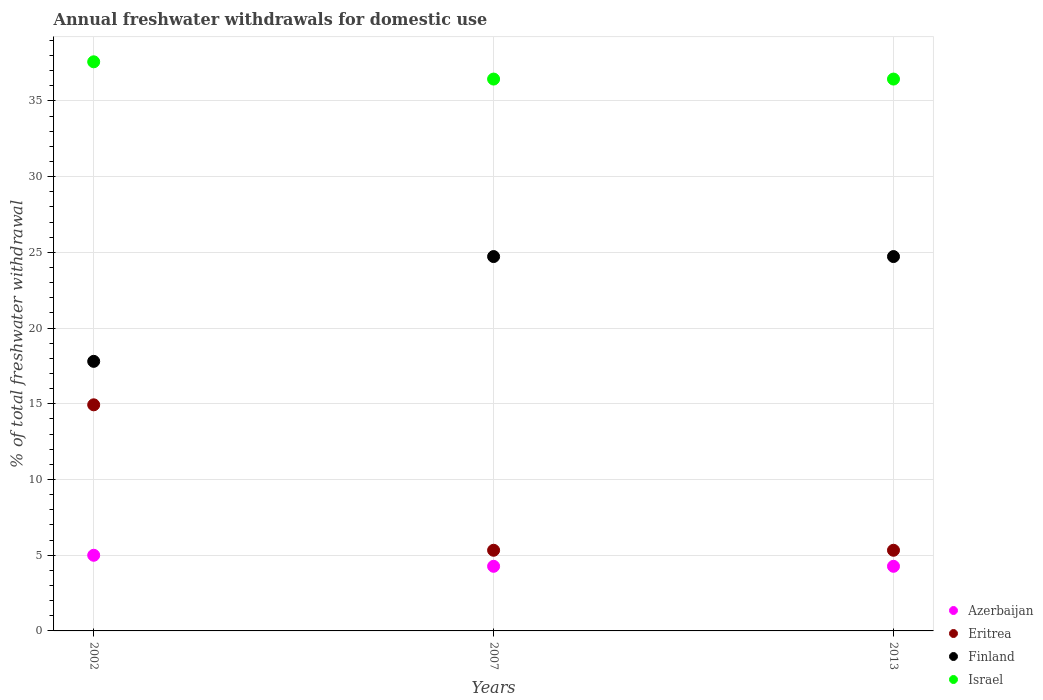What is the total annual withdrawals from freshwater in Eritrea in 2002?
Ensure brevity in your answer.  14.93. Across all years, what is the maximum total annual withdrawals from freshwater in Finland?
Ensure brevity in your answer.  24.72. In which year was the total annual withdrawals from freshwater in Finland maximum?
Give a very brief answer. 2007. What is the total total annual withdrawals from freshwater in Israel in the graph?
Your answer should be very brief. 110.46. What is the difference between the total annual withdrawals from freshwater in Finland in 2002 and that in 2013?
Give a very brief answer. -6.92. What is the difference between the total annual withdrawals from freshwater in Finland in 2002 and the total annual withdrawals from freshwater in Israel in 2013?
Your response must be concise. -18.64. What is the average total annual withdrawals from freshwater in Eritrea per year?
Keep it short and to the point. 8.53. In the year 2002, what is the difference between the total annual withdrawals from freshwater in Finland and total annual withdrawals from freshwater in Azerbaijan?
Your answer should be very brief. 12.8. In how many years, is the total annual withdrawals from freshwater in Azerbaijan greater than 14 %?
Your response must be concise. 0. What is the ratio of the total annual withdrawals from freshwater in Finland in 2002 to that in 2007?
Offer a terse response. 0.72. What is the difference between the highest and the second highest total annual withdrawals from freshwater in Israel?
Your answer should be very brief. 1.14. What is the difference between the highest and the lowest total annual withdrawals from freshwater in Finland?
Offer a terse response. 6.92. In how many years, is the total annual withdrawals from freshwater in Finland greater than the average total annual withdrawals from freshwater in Finland taken over all years?
Ensure brevity in your answer.  2. Is it the case that in every year, the sum of the total annual withdrawals from freshwater in Azerbaijan and total annual withdrawals from freshwater in Finland  is greater than the sum of total annual withdrawals from freshwater in Eritrea and total annual withdrawals from freshwater in Israel?
Ensure brevity in your answer.  Yes. Is it the case that in every year, the sum of the total annual withdrawals from freshwater in Israel and total annual withdrawals from freshwater in Azerbaijan  is greater than the total annual withdrawals from freshwater in Eritrea?
Make the answer very short. Yes. Does the total annual withdrawals from freshwater in Finland monotonically increase over the years?
Offer a very short reply. No. Is the total annual withdrawals from freshwater in Israel strictly greater than the total annual withdrawals from freshwater in Azerbaijan over the years?
Make the answer very short. Yes. Is the total annual withdrawals from freshwater in Azerbaijan strictly less than the total annual withdrawals from freshwater in Eritrea over the years?
Give a very brief answer. Yes. How many dotlines are there?
Provide a short and direct response. 4. How many years are there in the graph?
Offer a terse response. 3. What is the difference between two consecutive major ticks on the Y-axis?
Provide a short and direct response. 5. Are the values on the major ticks of Y-axis written in scientific E-notation?
Your answer should be compact. No. Does the graph contain any zero values?
Keep it short and to the point. No. How many legend labels are there?
Provide a short and direct response. 4. What is the title of the graph?
Make the answer very short. Annual freshwater withdrawals for domestic use. What is the label or title of the X-axis?
Your answer should be very brief. Years. What is the label or title of the Y-axis?
Keep it short and to the point. % of total freshwater withdrawal. What is the % of total freshwater withdrawal of Azerbaijan in 2002?
Your response must be concise. 5. What is the % of total freshwater withdrawal of Eritrea in 2002?
Make the answer very short. 14.93. What is the % of total freshwater withdrawal in Finland in 2002?
Ensure brevity in your answer.  17.8. What is the % of total freshwater withdrawal of Israel in 2002?
Offer a terse response. 37.58. What is the % of total freshwater withdrawal in Azerbaijan in 2007?
Keep it short and to the point. 4.27. What is the % of total freshwater withdrawal in Eritrea in 2007?
Your response must be concise. 5.33. What is the % of total freshwater withdrawal in Finland in 2007?
Provide a short and direct response. 24.72. What is the % of total freshwater withdrawal of Israel in 2007?
Your response must be concise. 36.44. What is the % of total freshwater withdrawal in Azerbaijan in 2013?
Provide a succinct answer. 4.27. What is the % of total freshwater withdrawal in Eritrea in 2013?
Your answer should be compact. 5.33. What is the % of total freshwater withdrawal of Finland in 2013?
Offer a very short reply. 24.72. What is the % of total freshwater withdrawal of Israel in 2013?
Make the answer very short. 36.44. Across all years, what is the maximum % of total freshwater withdrawal in Azerbaijan?
Ensure brevity in your answer.  5. Across all years, what is the maximum % of total freshwater withdrawal of Eritrea?
Your answer should be very brief. 14.93. Across all years, what is the maximum % of total freshwater withdrawal of Finland?
Offer a very short reply. 24.72. Across all years, what is the maximum % of total freshwater withdrawal in Israel?
Your response must be concise. 37.58. Across all years, what is the minimum % of total freshwater withdrawal in Azerbaijan?
Give a very brief answer. 4.27. Across all years, what is the minimum % of total freshwater withdrawal of Eritrea?
Your answer should be very brief. 5.33. Across all years, what is the minimum % of total freshwater withdrawal of Finland?
Make the answer very short. 17.8. Across all years, what is the minimum % of total freshwater withdrawal in Israel?
Offer a very short reply. 36.44. What is the total % of total freshwater withdrawal in Azerbaijan in the graph?
Your answer should be very brief. 13.53. What is the total % of total freshwater withdrawal in Eritrea in the graph?
Give a very brief answer. 25.58. What is the total % of total freshwater withdrawal of Finland in the graph?
Offer a very short reply. 67.24. What is the total % of total freshwater withdrawal in Israel in the graph?
Offer a very short reply. 110.46. What is the difference between the % of total freshwater withdrawal of Azerbaijan in 2002 and that in 2007?
Offer a very short reply. 0.73. What is the difference between the % of total freshwater withdrawal of Eritrea in 2002 and that in 2007?
Give a very brief answer. 9.6. What is the difference between the % of total freshwater withdrawal in Finland in 2002 and that in 2007?
Provide a succinct answer. -6.92. What is the difference between the % of total freshwater withdrawal of Israel in 2002 and that in 2007?
Your answer should be compact. 1.14. What is the difference between the % of total freshwater withdrawal of Azerbaijan in 2002 and that in 2013?
Keep it short and to the point. 0.73. What is the difference between the % of total freshwater withdrawal of Eritrea in 2002 and that in 2013?
Keep it short and to the point. 9.6. What is the difference between the % of total freshwater withdrawal in Finland in 2002 and that in 2013?
Ensure brevity in your answer.  -6.92. What is the difference between the % of total freshwater withdrawal of Israel in 2002 and that in 2013?
Give a very brief answer. 1.14. What is the difference between the % of total freshwater withdrawal of Azerbaijan in 2007 and that in 2013?
Make the answer very short. 0. What is the difference between the % of total freshwater withdrawal in Eritrea in 2007 and that in 2013?
Offer a very short reply. 0. What is the difference between the % of total freshwater withdrawal of Finland in 2007 and that in 2013?
Provide a short and direct response. 0. What is the difference between the % of total freshwater withdrawal in Israel in 2007 and that in 2013?
Offer a very short reply. 0. What is the difference between the % of total freshwater withdrawal in Azerbaijan in 2002 and the % of total freshwater withdrawal in Eritrea in 2007?
Give a very brief answer. -0.33. What is the difference between the % of total freshwater withdrawal in Azerbaijan in 2002 and the % of total freshwater withdrawal in Finland in 2007?
Ensure brevity in your answer.  -19.73. What is the difference between the % of total freshwater withdrawal of Azerbaijan in 2002 and the % of total freshwater withdrawal of Israel in 2007?
Offer a very short reply. -31.45. What is the difference between the % of total freshwater withdrawal in Eritrea in 2002 and the % of total freshwater withdrawal in Finland in 2007?
Ensure brevity in your answer.  -9.79. What is the difference between the % of total freshwater withdrawal in Eritrea in 2002 and the % of total freshwater withdrawal in Israel in 2007?
Your answer should be very brief. -21.51. What is the difference between the % of total freshwater withdrawal in Finland in 2002 and the % of total freshwater withdrawal in Israel in 2007?
Keep it short and to the point. -18.64. What is the difference between the % of total freshwater withdrawal of Azerbaijan in 2002 and the % of total freshwater withdrawal of Eritrea in 2013?
Give a very brief answer. -0.33. What is the difference between the % of total freshwater withdrawal of Azerbaijan in 2002 and the % of total freshwater withdrawal of Finland in 2013?
Keep it short and to the point. -19.73. What is the difference between the % of total freshwater withdrawal of Azerbaijan in 2002 and the % of total freshwater withdrawal of Israel in 2013?
Offer a very short reply. -31.45. What is the difference between the % of total freshwater withdrawal of Eritrea in 2002 and the % of total freshwater withdrawal of Finland in 2013?
Provide a succinct answer. -9.79. What is the difference between the % of total freshwater withdrawal of Eritrea in 2002 and the % of total freshwater withdrawal of Israel in 2013?
Keep it short and to the point. -21.51. What is the difference between the % of total freshwater withdrawal in Finland in 2002 and the % of total freshwater withdrawal in Israel in 2013?
Your answer should be very brief. -18.64. What is the difference between the % of total freshwater withdrawal in Azerbaijan in 2007 and the % of total freshwater withdrawal in Eritrea in 2013?
Your answer should be compact. -1.06. What is the difference between the % of total freshwater withdrawal of Azerbaijan in 2007 and the % of total freshwater withdrawal of Finland in 2013?
Provide a succinct answer. -20.45. What is the difference between the % of total freshwater withdrawal in Azerbaijan in 2007 and the % of total freshwater withdrawal in Israel in 2013?
Keep it short and to the point. -32.17. What is the difference between the % of total freshwater withdrawal in Eritrea in 2007 and the % of total freshwater withdrawal in Finland in 2013?
Your answer should be very brief. -19.39. What is the difference between the % of total freshwater withdrawal in Eritrea in 2007 and the % of total freshwater withdrawal in Israel in 2013?
Your answer should be compact. -31.11. What is the difference between the % of total freshwater withdrawal in Finland in 2007 and the % of total freshwater withdrawal in Israel in 2013?
Your answer should be very brief. -11.72. What is the average % of total freshwater withdrawal of Azerbaijan per year?
Provide a short and direct response. 4.51. What is the average % of total freshwater withdrawal of Eritrea per year?
Offer a very short reply. 8.53. What is the average % of total freshwater withdrawal in Finland per year?
Offer a very short reply. 22.41. What is the average % of total freshwater withdrawal of Israel per year?
Your response must be concise. 36.82. In the year 2002, what is the difference between the % of total freshwater withdrawal in Azerbaijan and % of total freshwater withdrawal in Eritrea?
Your answer should be very brief. -9.94. In the year 2002, what is the difference between the % of total freshwater withdrawal in Azerbaijan and % of total freshwater withdrawal in Finland?
Provide a short and direct response. -12.8. In the year 2002, what is the difference between the % of total freshwater withdrawal of Azerbaijan and % of total freshwater withdrawal of Israel?
Keep it short and to the point. -32.59. In the year 2002, what is the difference between the % of total freshwater withdrawal in Eritrea and % of total freshwater withdrawal in Finland?
Provide a succinct answer. -2.87. In the year 2002, what is the difference between the % of total freshwater withdrawal of Eritrea and % of total freshwater withdrawal of Israel?
Ensure brevity in your answer.  -22.65. In the year 2002, what is the difference between the % of total freshwater withdrawal in Finland and % of total freshwater withdrawal in Israel?
Give a very brief answer. -19.78. In the year 2007, what is the difference between the % of total freshwater withdrawal in Azerbaijan and % of total freshwater withdrawal in Eritrea?
Offer a terse response. -1.06. In the year 2007, what is the difference between the % of total freshwater withdrawal in Azerbaijan and % of total freshwater withdrawal in Finland?
Provide a short and direct response. -20.45. In the year 2007, what is the difference between the % of total freshwater withdrawal of Azerbaijan and % of total freshwater withdrawal of Israel?
Your response must be concise. -32.17. In the year 2007, what is the difference between the % of total freshwater withdrawal of Eritrea and % of total freshwater withdrawal of Finland?
Provide a succinct answer. -19.39. In the year 2007, what is the difference between the % of total freshwater withdrawal of Eritrea and % of total freshwater withdrawal of Israel?
Provide a short and direct response. -31.11. In the year 2007, what is the difference between the % of total freshwater withdrawal in Finland and % of total freshwater withdrawal in Israel?
Ensure brevity in your answer.  -11.72. In the year 2013, what is the difference between the % of total freshwater withdrawal of Azerbaijan and % of total freshwater withdrawal of Eritrea?
Provide a short and direct response. -1.06. In the year 2013, what is the difference between the % of total freshwater withdrawal in Azerbaijan and % of total freshwater withdrawal in Finland?
Your response must be concise. -20.45. In the year 2013, what is the difference between the % of total freshwater withdrawal of Azerbaijan and % of total freshwater withdrawal of Israel?
Keep it short and to the point. -32.17. In the year 2013, what is the difference between the % of total freshwater withdrawal in Eritrea and % of total freshwater withdrawal in Finland?
Provide a succinct answer. -19.39. In the year 2013, what is the difference between the % of total freshwater withdrawal in Eritrea and % of total freshwater withdrawal in Israel?
Your response must be concise. -31.11. In the year 2013, what is the difference between the % of total freshwater withdrawal of Finland and % of total freshwater withdrawal of Israel?
Provide a short and direct response. -11.72. What is the ratio of the % of total freshwater withdrawal in Azerbaijan in 2002 to that in 2007?
Your answer should be compact. 1.17. What is the ratio of the % of total freshwater withdrawal of Eritrea in 2002 to that in 2007?
Keep it short and to the point. 2.8. What is the ratio of the % of total freshwater withdrawal of Finland in 2002 to that in 2007?
Your response must be concise. 0.72. What is the ratio of the % of total freshwater withdrawal of Israel in 2002 to that in 2007?
Your answer should be compact. 1.03. What is the ratio of the % of total freshwater withdrawal in Azerbaijan in 2002 to that in 2013?
Your answer should be very brief. 1.17. What is the ratio of the % of total freshwater withdrawal of Eritrea in 2002 to that in 2013?
Give a very brief answer. 2.8. What is the ratio of the % of total freshwater withdrawal in Finland in 2002 to that in 2013?
Offer a very short reply. 0.72. What is the ratio of the % of total freshwater withdrawal in Israel in 2002 to that in 2013?
Offer a very short reply. 1.03. What is the ratio of the % of total freshwater withdrawal in Azerbaijan in 2007 to that in 2013?
Make the answer very short. 1. What is the ratio of the % of total freshwater withdrawal of Finland in 2007 to that in 2013?
Give a very brief answer. 1. What is the ratio of the % of total freshwater withdrawal of Israel in 2007 to that in 2013?
Keep it short and to the point. 1. What is the difference between the highest and the second highest % of total freshwater withdrawal of Azerbaijan?
Your answer should be very brief. 0.73. What is the difference between the highest and the second highest % of total freshwater withdrawal in Eritrea?
Provide a succinct answer. 9.6. What is the difference between the highest and the second highest % of total freshwater withdrawal in Finland?
Your answer should be compact. 0. What is the difference between the highest and the second highest % of total freshwater withdrawal in Israel?
Offer a terse response. 1.14. What is the difference between the highest and the lowest % of total freshwater withdrawal of Azerbaijan?
Give a very brief answer. 0.73. What is the difference between the highest and the lowest % of total freshwater withdrawal in Eritrea?
Your answer should be compact. 9.6. What is the difference between the highest and the lowest % of total freshwater withdrawal in Finland?
Provide a short and direct response. 6.92. What is the difference between the highest and the lowest % of total freshwater withdrawal in Israel?
Your response must be concise. 1.14. 